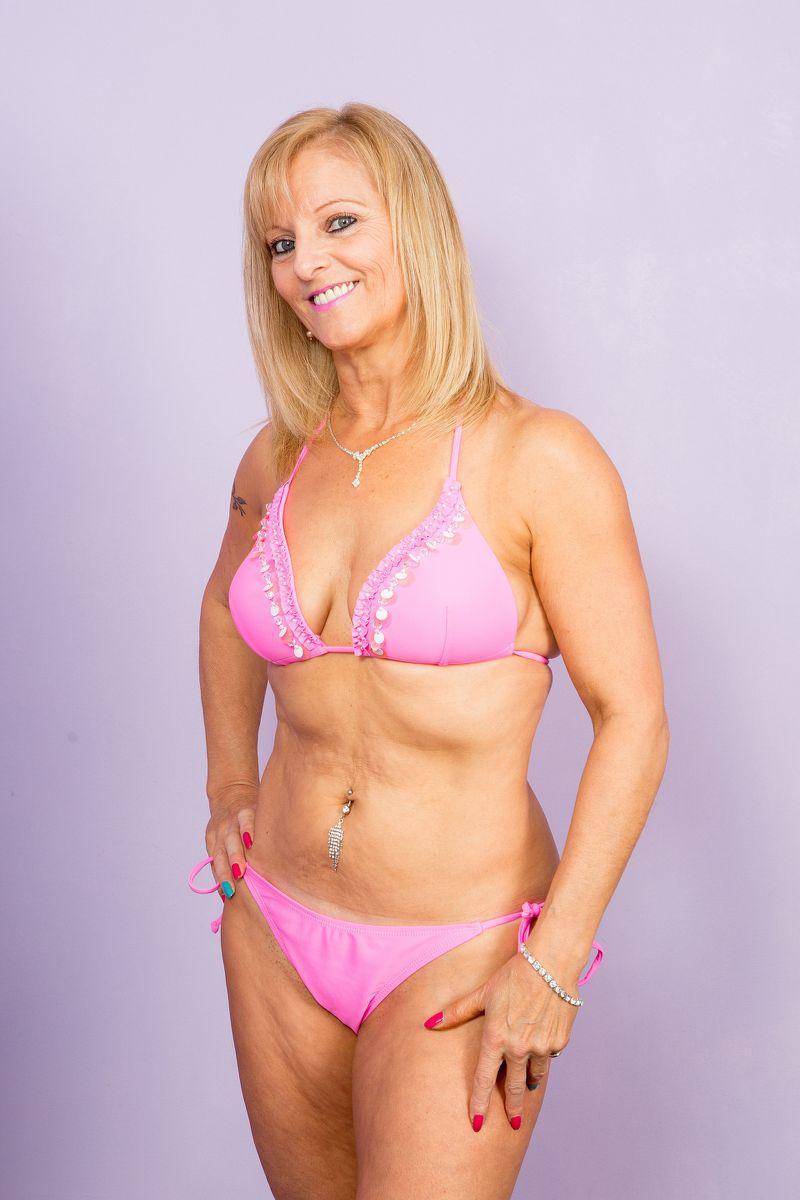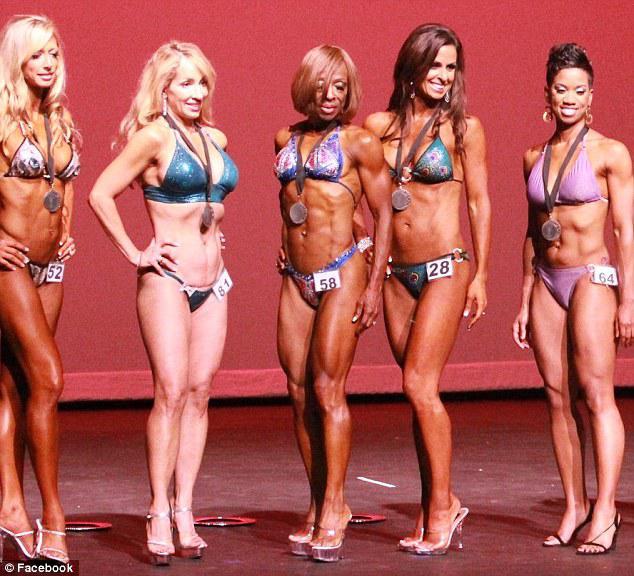The first image is the image on the left, the second image is the image on the right. Analyze the images presented: Is the assertion "A woman is wearing a red polka dot swimsuit." valid? Answer yes or no. No. The first image is the image on the left, the second image is the image on the right. For the images shown, is this caption "An image shows a trio of swimwear models, with at least one wearing a one-piece suit." true? Answer yes or no. No. 